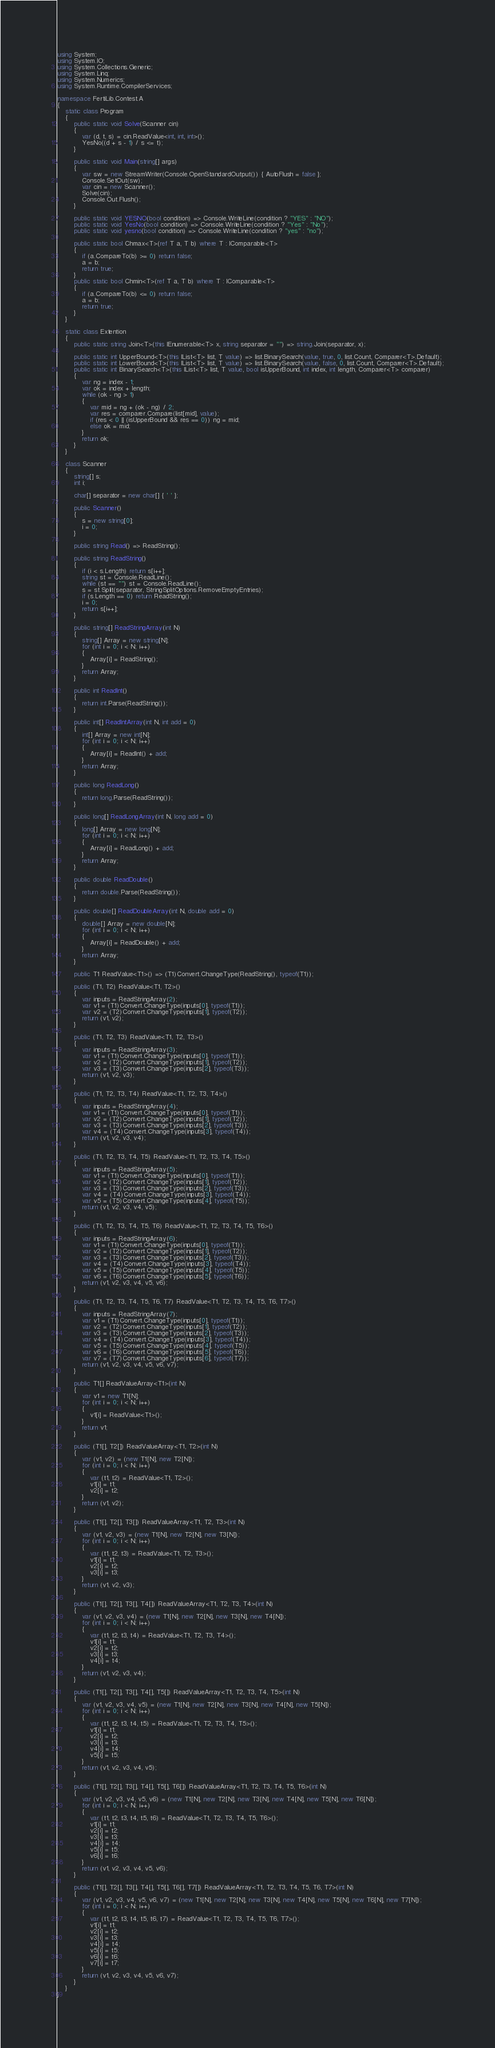<code> <loc_0><loc_0><loc_500><loc_500><_C#_>using System;
using System.IO;
using System.Collections.Generic;
using System.Linq;
using System.Numerics;
using System.Runtime.CompilerServices;

namespace FertiLib.Contest.A
{
	static class Program
	{
		public static void Solve(Scanner cin)
		{
			var (d, t, s) = cin.ReadValue<int, int, int>();
			YesNo((d + s - 1) / s <= t);
		}

		public static void Main(string[] args)
		{
			var sw = new StreamWriter(Console.OpenStandardOutput()) { AutoFlush = false };
			Console.SetOut(sw);
			var cin = new Scanner();
			Solve(cin);
			Console.Out.Flush();
		}

		public static void YESNO(bool condition) => Console.WriteLine(condition ? "YES" : "NO");
		public static void YesNo(bool condition) => Console.WriteLine(condition ? "Yes" : "No");
		public static void yesno(bool condition) => Console.WriteLine(condition ? "yes" : "no");

		public static bool Chmax<T>(ref T a, T b) where T : IComparable<T>
		{
			if (a.CompareTo(b) >= 0) return false;
			a = b;
			return true;
		}
		public static bool Chmin<T>(ref T a, T b) where T : IComparable<T>
		{
			if (a.CompareTo(b) <= 0) return false;
			a = b;
			return true;
		}
	}

	static class Extention
	{
		public static string Join<T>(this IEnumerable<T> x, string separator = "") => string.Join(separator, x);

		public static int UpperBound<T>(this IList<T> list, T value) => list.BinarySearch(value, true, 0, list.Count, Comparer<T>.Default);
		public static int LowerBound<T>(this IList<T> list, T value) => list.BinarySearch(value, false, 0, list.Count, Comparer<T>.Default);
		public static int BinarySearch<T>(this IList<T> list, T value, bool isUpperBound, int index, int length, Comparer<T> comparer)
		{
			var ng = index - 1;
			var ok = index + length;
			while (ok - ng > 1)
			{
				var mid = ng + (ok - ng) / 2;
				var res = comparer.Compare(list[mid], value);
				if (res < 0 || (isUpperBound && res == 0)) ng = mid;
				else ok = mid;
			}
			return ok;
		}
	}

	class Scanner
	{
		string[] s;
		int i;

		char[] separator = new char[] { ' ' };

		public Scanner()
		{
			s = new string[0];
			i = 0;
		}

		public string Read() => ReadString();

		public string ReadString()
		{
			if (i < s.Length) return s[i++];
			string st = Console.ReadLine();
			while (st == "") st = Console.ReadLine();
			s = st.Split(separator, StringSplitOptions.RemoveEmptyEntries);
			if (s.Length == 0) return ReadString();
			i = 0;
			return s[i++];
		}

		public string[] ReadStringArray(int N)
		{
			string[] Array = new string[N];
			for (int i = 0; i < N; i++)
			{
				Array[i] = ReadString();
			}
			return Array;
		}

		public int ReadInt()
		{
			return int.Parse(ReadString());
		}

		public int[] ReadIntArray(int N, int add = 0)
		{
			int[] Array = new int[N];
			for (int i = 0; i < N; i++)
			{
				Array[i] = ReadInt() + add;
			}
			return Array;
		}

		public long ReadLong()
		{
			return long.Parse(ReadString());
		}

		public long[] ReadLongArray(int N, long add = 0)
		{
			long[] Array = new long[N];
			for (int i = 0; i < N; i++)
			{
				Array[i] = ReadLong() + add;
			}
			return Array;
		}

		public double ReadDouble()
		{
			return double.Parse(ReadString());
		}

		public double[] ReadDoubleArray(int N, double add = 0)
		{
			double[] Array = new double[N];
			for (int i = 0; i < N; i++)
			{
				Array[i] = ReadDouble() + add;
			}
			return Array;
		}

		public T1 ReadValue<T1>() => (T1)Convert.ChangeType(ReadString(), typeof(T1));

		public (T1, T2) ReadValue<T1, T2>()
		{
			var inputs = ReadStringArray(2);
			var v1 = (T1)Convert.ChangeType(inputs[0], typeof(T1));
			var v2 = (T2)Convert.ChangeType(inputs[1], typeof(T2));
			return (v1, v2);
		}

		public (T1, T2, T3) ReadValue<T1, T2, T3>()
		{
			var inputs = ReadStringArray(3);
			var v1 = (T1)Convert.ChangeType(inputs[0], typeof(T1));
			var v2 = (T2)Convert.ChangeType(inputs[1], typeof(T2));
			var v3 = (T3)Convert.ChangeType(inputs[2], typeof(T3));
			return (v1, v2, v3);
		}

		public (T1, T2, T3, T4) ReadValue<T1, T2, T3, T4>()
		{
			var inputs = ReadStringArray(4);
			var v1 = (T1)Convert.ChangeType(inputs[0], typeof(T1));
			var v2 = (T2)Convert.ChangeType(inputs[1], typeof(T2));
			var v3 = (T3)Convert.ChangeType(inputs[2], typeof(T3));
			var v4 = (T4)Convert.ChangeType(inputs[3], typeof(T4));
			return (v1, v2, v3, v4);
		}

		public (T1, T2, T3, T4, T5) ReadValue<T1, T2, T3, T4, T5>()
		{
			var inputs = ReadStringArray(5);
			var v1 = (T1)Convert.ChangeType(inputs[0], typeof(T1));
			var v2 = (T2)Convert.ChangeType(inputs[1], typeof(T2));
			var v3 = (T3)Convert.ChangeType(inputs[2], typeof(T3));
			var v4 = (T4)Convert.ChangeType(inputs[3], typeof(T4));
			var v5 = (T5)Convert.ChangeType(inputs[4], typeof(T5));
			return (v1, v2, v3, v4, v5);
		}

		public (T1, T2, T3, T4, T5, T6) ReadValue<T1, T2, T3, T4, T5, T6>()
		{
			var inputs = ReadStringArray(6);
			var v1 = (T1)Convert.ChangeType(inputs[0], typeof(T1));
			var v2 = (T2)Convert.ChangeType(inputs[1], typeof(T2));
			var v3 = (T3)Convert.ChangeType(inputs[2], typeof(T3));
			var v4 = (T4)Convert.ChangeType(inputs[3], typeof(T4));
			var v5 = (T5)Convert.ChangeType(inputs[4], typeof(T5));
			var v6 = (T6)Convert.ChangeType(inputs[5], typeof(T6));
			return (v1, v2, v3, v4, v5, v6);
		}

		public (T1, T2, T3, T4, T5, T6, T7) ReadValue<T1, T2, T3, T4, T5, T6, T7>()
		{
			var inputs = ReadStringArray(7);
			var v1 = (T1)Convert.ChangeType(inputs[0], typeof(T1));
			var v2 = (T2)Convert.ChangeType(inputs[1], typeof(T2));
			var v3 = (T3)Convert.ChangeType(inputs[2], typeof(T3));
			var v4 = (T4)Convert.ChangeType(inputs[3], typeof(T4));
			var v5 = (T5)Convert.ChangeType(inputs[4], typeof(T5));
			var v6 = (T6)Convert.ChangeType(inputs[5], typeof(T6));
			var v7 = (T7)Convert.ChangeType(inputs[6], typeof(T7));
			return (v1, v2, v3, v4, v5, v6, v7);
		}

		public T1[] ReadValueArray<T1>(int N)
		{
			var v1 = new T1[N];
			for (int i = 0; i < N; i++)
			{
				v1[i] = ReadValue<T1>();
			}
			return v1;
		}

		public (T1[], T2[]) ReadValueArray<T1, T2>(int N)
		{
			var (v1, v2) = (new T1[N], new T2[N]);
			for (int i = 0; i < N; i++)
			{
				var (t1, t2) = ReadValue<T1, T2>();
				v1[i] = t1;
				v2[i] = t2;
			}
			return (v1, v2);
		}

		public (T1[], T2[], T3[]) ReadValueArray<T1, T2, T3>(int N)
		{
			var (v1, v2, v3) = (new T1[N], new T2[N], new T3[N]);
			for (int i = 0; i < N; i++)
			{
				var (t1, t2, t3) = ReadValue<T1, T2, T3>();
				v1[i] = t1;
				v2[i] = t2;
				v3[i] = t3;
			}
			return (v1, v2, v3);
		}

		public (T1[], T2[], T3[], T4[]) ReadValueArray<T1, T2, T3, T4>(int N)
		{
			var (v1, v2, v3, v4) = (new T1[N], new T2[N], new T3[N], new T4[N]);
			for (int i = 0; i < N; i++)
			{
				var (t1, t2, t3, t4) = ReadValue<T1, T2, T3, T4>();
				v1[i] = t1;
				v2[i] = t2;
				v3[i] = t3;
				v4[i] = t4;
			}
			return (v1, v2, v3, v4);
		}

		public (T1[], T2[], T3[], T4[], T5[]) ReadValueArray<T1, T2, T3, T4, T5>(int N)
		{
			var (v1, v2, v3, v4, v5) = (new T1[N], new T2[N], new T3[N], new T4[N], new T5[N]);
			for (int i = 0; i < N; i++)
			{
				var (t1, t2, t3, t4, t5) = ReadValue<T1, T2, T3, T4, T5>();
				v1[i] = t1;
				v2[i] = t2;
				v3[i] = t3;
				v4[i] = t4;
				v5[i] = t5;
			}
			return (v1, v2, v3, v4, v5);
		}

		public (T1[], T2[], T3[], T4[], T5[], T6[]) ReadValueArray<T1, T2, T3, T4, T5, T6>(int N)
		{
			var (v1, v2, v3, v4, v5, v6) = (new T1[N], new T2[N], new T3[N], new T4[N], new T5[N], new T6[N]);
			for (int i = 0; i < N; i++)
			{
				var (t1, t2, t3, t4, t5, t6) = ReadValue<T1, T2, T3, T4, T5, T6>();
				v1[i] = t1;
				v2[i] = t2;
				v3[i] = t3;
				v4[i] = t4;
				v5[i] = t5;
				v6[i] = t6;
			}
			return (v1, v2, v3, v4, v5, v6);
		}

		public (T1[], T2[], T3[], T4[], T5[], T6[], T7[]) ReadValueArray<T1, T2, T3, T4, T5, T6, T7>(int N)
		{
			var (v1, v2, v3, v4, v5, v6, v7) = (new T1[N], new T2[N], new T3[N], new T4[N], new T5[N], new T6[N], new T7[N]);
			for (int i = 0; i < N; i++)
			{
				var (t1, t2, t3, t4, t5, t6, t7) = ReadValue<T1, T2, T3, T4, T5, T6, T7>();
				v1[i] = t1;
				v2[i] = t2;
				v3[i] = t3;
				v4[i] = t4;
				v5[i] = t5;
				v6[i] = t6;
				v7[i] = t7;
			}
			return (v1, v2, v3, v4, v5, v6, v7);
		}
	}
}
</code> 